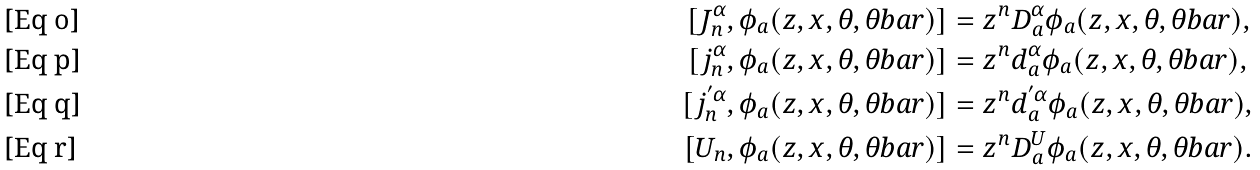<formula> <loc_0><loc_0><loc_500><loc_500>[ J _ { n } ^ { \alpha } , \phi _ { a } ( z , x , \theta , \theta b a r ) ] & = z ^ { n } D ^ { \alpha } _ { a } \phi _ { a } ( z , x , \theta , \theta b a r ) , \\ [ j _ { n } ^ { \alpha } , \phi _ { a } ( z , x , \theta , \theta b a r ) ] & = z ^ { n } d ^ { \alpha } _ { a } \phi _ { a } ( z , x , \theta , \theta b a r ) , \\ [ j _ { n } ^ { ^ { \prime } \alpha } , \phi _ { a } ( z , x , \theta , \theta b a r ) ] & = z ^ { n } d ^ { ^ { \prime } \alpha } _ { a } \phi _ { a } ( z , x , \theta , \theta b a r ) , \\ [ U _ { n } , \phi _ { a } ( z , x , \theta , \theta b a r ) ] & = z ^ { n } D ^ { U } _ { a } \phi _ { a } ( z , x , \theta , \theta b a r ) .</formula> 